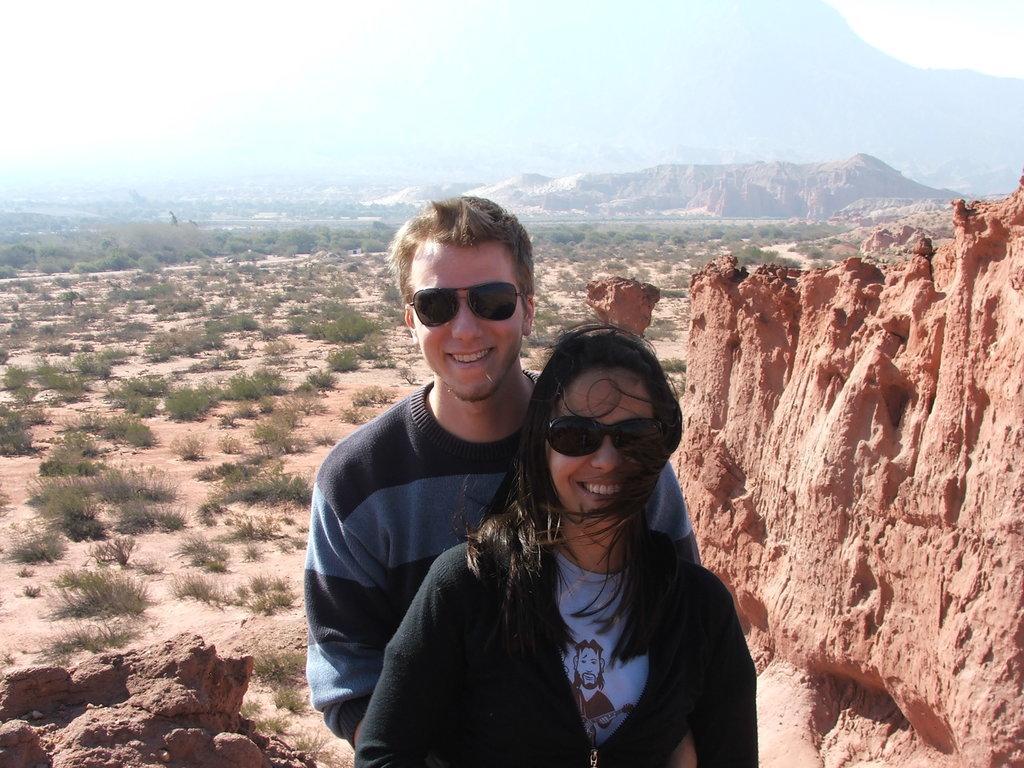Please provide a concise description of this image. In this image in the foreground there is one man and one woman standing, and they are wearing goggles. And in the background there are mountains, plants, sand and at the bottom there are some rocks. And on the right side of the image there is mountain. 